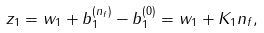Convert formula to latex. <formula><loc_0><loc_0><loc_500><loc_500>z _ { 1 } = w _ { 1 } + b _ { 1 } ^ { ( n _ { f } ) } - b _ { 1 } ^ { ( 0 ) } = w _ { 1 } + K _ { 1 } n _ { f } ,</formula> 